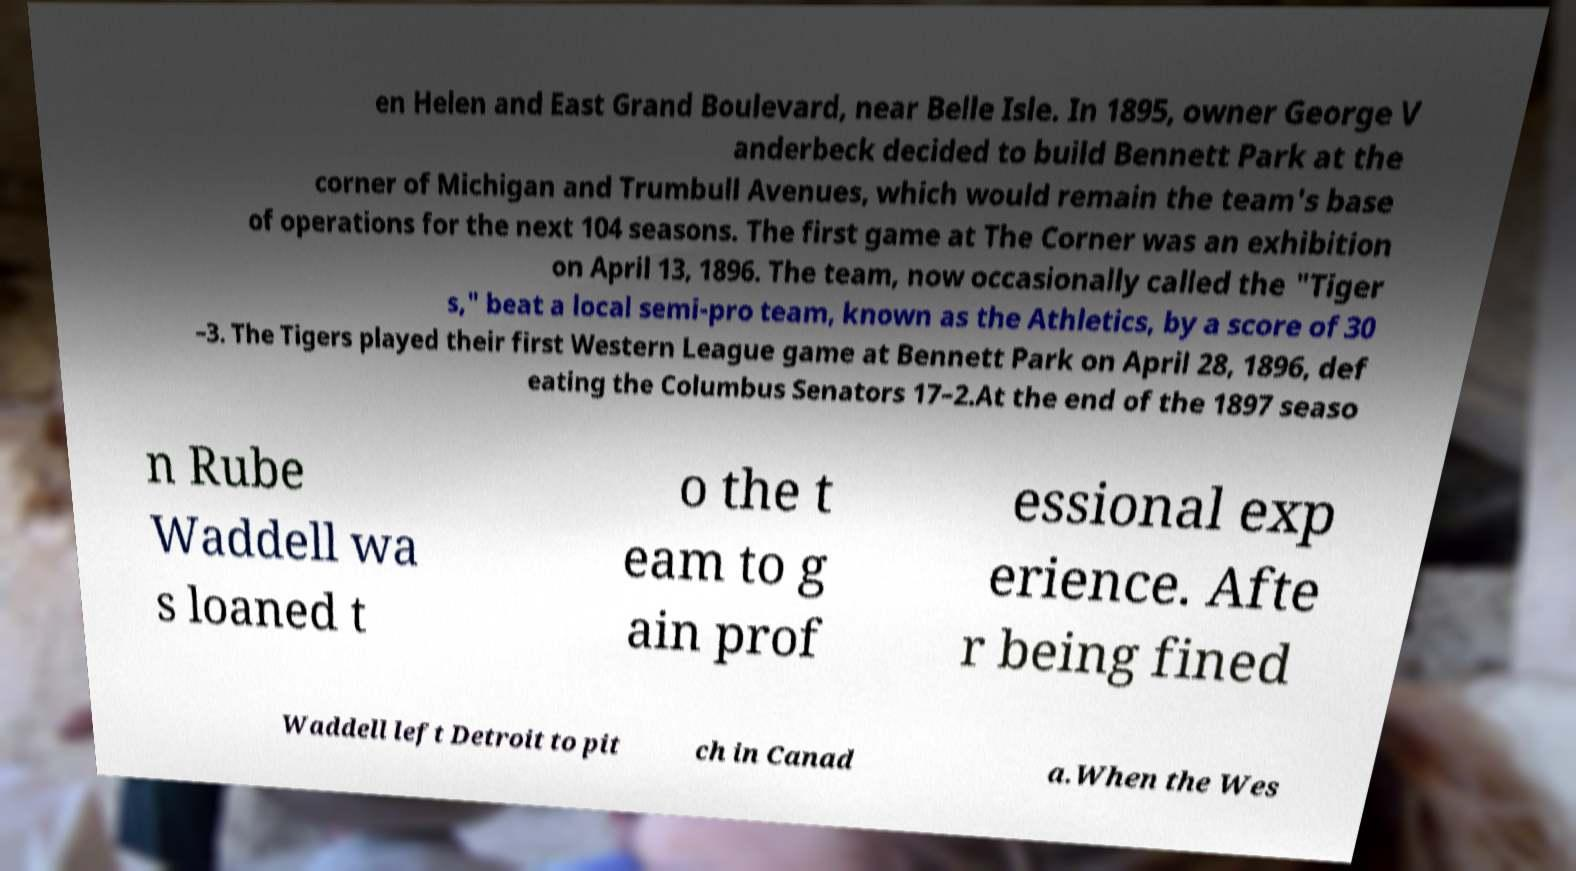Please read and relay the text visible in this image. What does it say? en Helen and East Grand Boulevard, near Belle Isle. In 1895, owner George V anderbeck decided to build Bennett Park at the corner of Michigan and Trumbull Avenues, which would remain the team's base of operations for the next 104 seasons. The first game at The Corner was an exhibition on April 13, 1896. The team, now occasionally called the "Tiger s," beat a local semi-pro team, known as the Athletics, by a score of 30 –3. The Tigers played their first Western League game at Bennett Park on April 28, 1896, def eating the Columbus Senators 17–2.At the end of the 1897 seaso n Rube Waddell wa s loaned t o the t eam to g ain prof essional exp erience. Afte r being fined Waddell left Detroit to pit ch in Canad a.When the Wes 